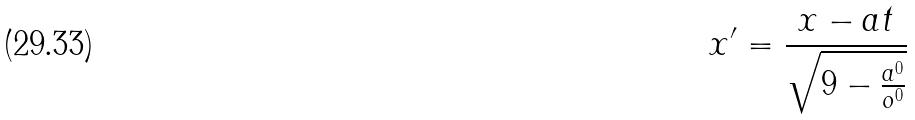Convert formula to latex. <formula><loc_0><loc_0><loc_500><loc_500>x ^ { \prime } = \frac { x - a t } { \sqrt { 9 - \frac { a ^ { 0 } } { o ^ { 0 } } } }</formula> 